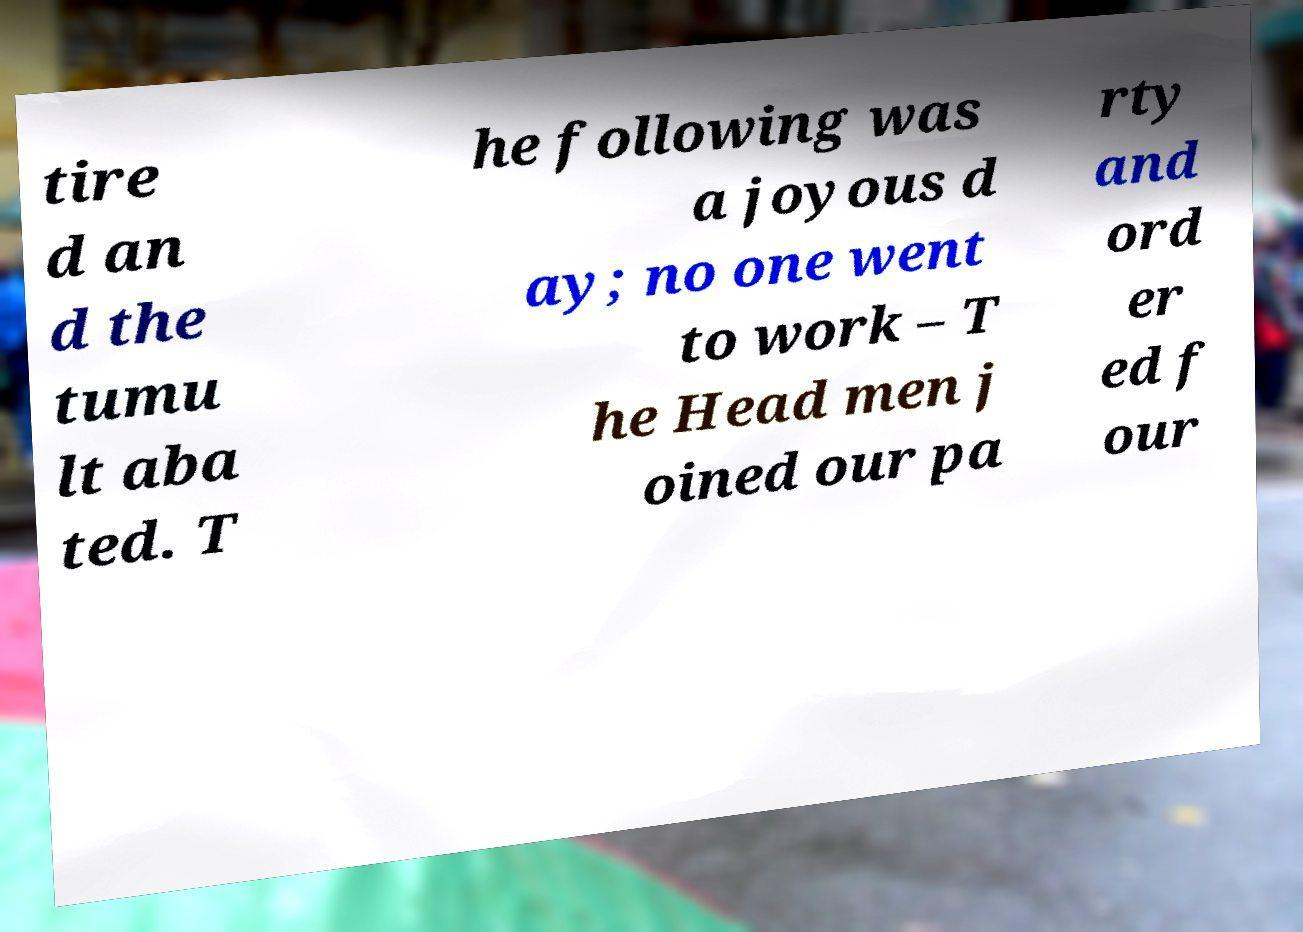Please identify and transcribe the text found in this image. tire d an d the tumu lt aba ted. T he following was a joyous d ay; no one went to work – T he Head men j oined our pa rty and ord er ed f our 